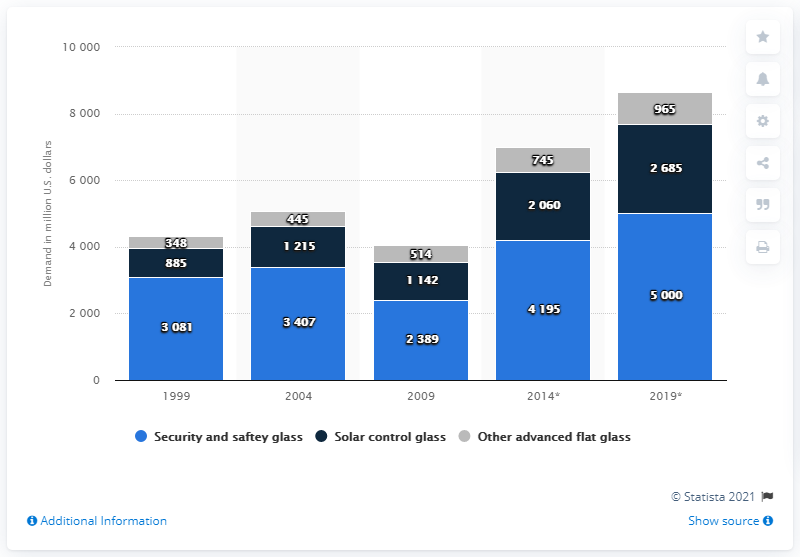Highlight a few significant elements in this photo. The projected demand for security and safety glass in 2019 is expected to be around 5,000 units. In 1999, the demand for security and safety glass was 3081. 